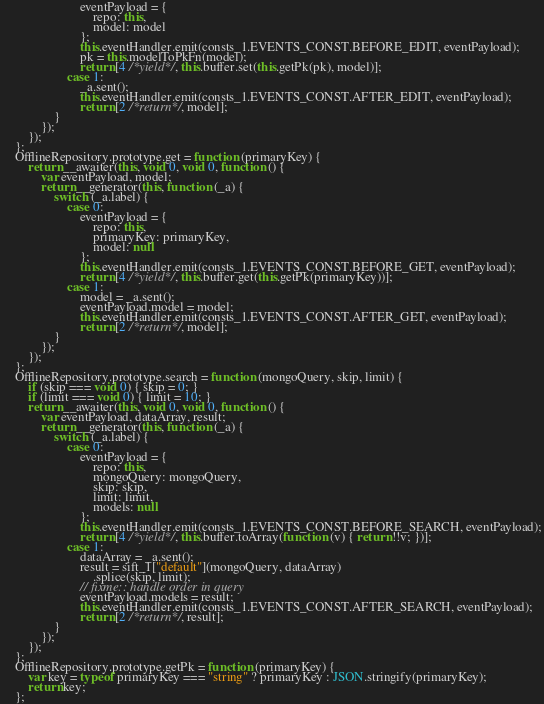<code> <loc_0><loc_0><loc_500><loc_500><_JavaScript_>                        eventPayload = {
                            repo: this,
                            model: model
                        };
                        this.eventHandler.emit(consts_1.EVENTS_CONST.BEFORE_EDIT, eventPayload);
                        pk = this.modelToPkFn(model);
                        return [4 /*yield*/, this.buffer.set(this.getPk(pk), model)];
                    case 1:
                        _a.sent();
                        this.eventHandler.emit(consts_1.EVENTS_CONST.AFTER_EDIT, eventPayload);
                        return [2 /*return*/, model];
                }
            });
        });
    };
    OfflineRepository.prototype.get = function (primaryKey) {
        return __awaiter(this, void 0, void 0, function () {
            var eventPayload, model;
            return __generator(this, function (_a) {
                switch (_a.label) {
                    case 0:
                        eventPayload = {
                            repo: this,
                            primaryKey: primaryKey,
                            model: null
                        };
                        this.eventHandler.emit(consts_1.EVENTS_CONST.BEFORE_GET, eventPayload);
                        return [4 /*yield*/, this.buffer.get(this.getPk(primaryKey))];
                    case 1:
                        model = _a.sent();
                        eventPayload.model = model;
                        this.eventHandler.emit(consts_1.EVENTS_CONST.AFTER_GET, eventPayload);
                        return [2 /*return*/, model];
                }
            });
        });
    };
    OfflineRepository.prototype.search = function (mongoQuery, skip, limit) {
        if (skip === void 0) { skip = 0; }
        if (limit === void 0) { limit = 10; }
        return __awaiter(this, void 0, void 0, function () {
            var eventPayload, dataArray, result;
            return __generator(this, function (_a) {
                switch (_a.label) {
                    case 0:
                        eventPayload = {
                            repo: this,
                            mongoQuery: mongoQuery,
                            skip: skip,
                            limit: limit,
                            models: null
                        };
                        this.eventHandler.emit(consts_1.EVENTS_CONST.BEFORE_SEARCH, eventPayload);
                        return [4 /*yield*/, this.buffer.toArray(function (v) { return !!v; })];
                    case 1:
                        dataArray = _a.sent();
                        result = sift_1["default"](mongoQuery, dataArray)
                            .splice(skip, limit);
                        // fixme:: handle order in query
                        eventPayload.models = result;
                        this.eventHandler.emit(consts_1.EVENTS_CONST.AFTER_SEARCH, eventPayload);
                        return [2 /*return*/, result];
                }
            });
        });
    };
    OfflineRepository.prototype.getPk = function (primaryKey) {
        var key = typeof primaryKey === "string" ? primaryKey : JSON.stringify(primaryKey);
        return key;
    };</code> 